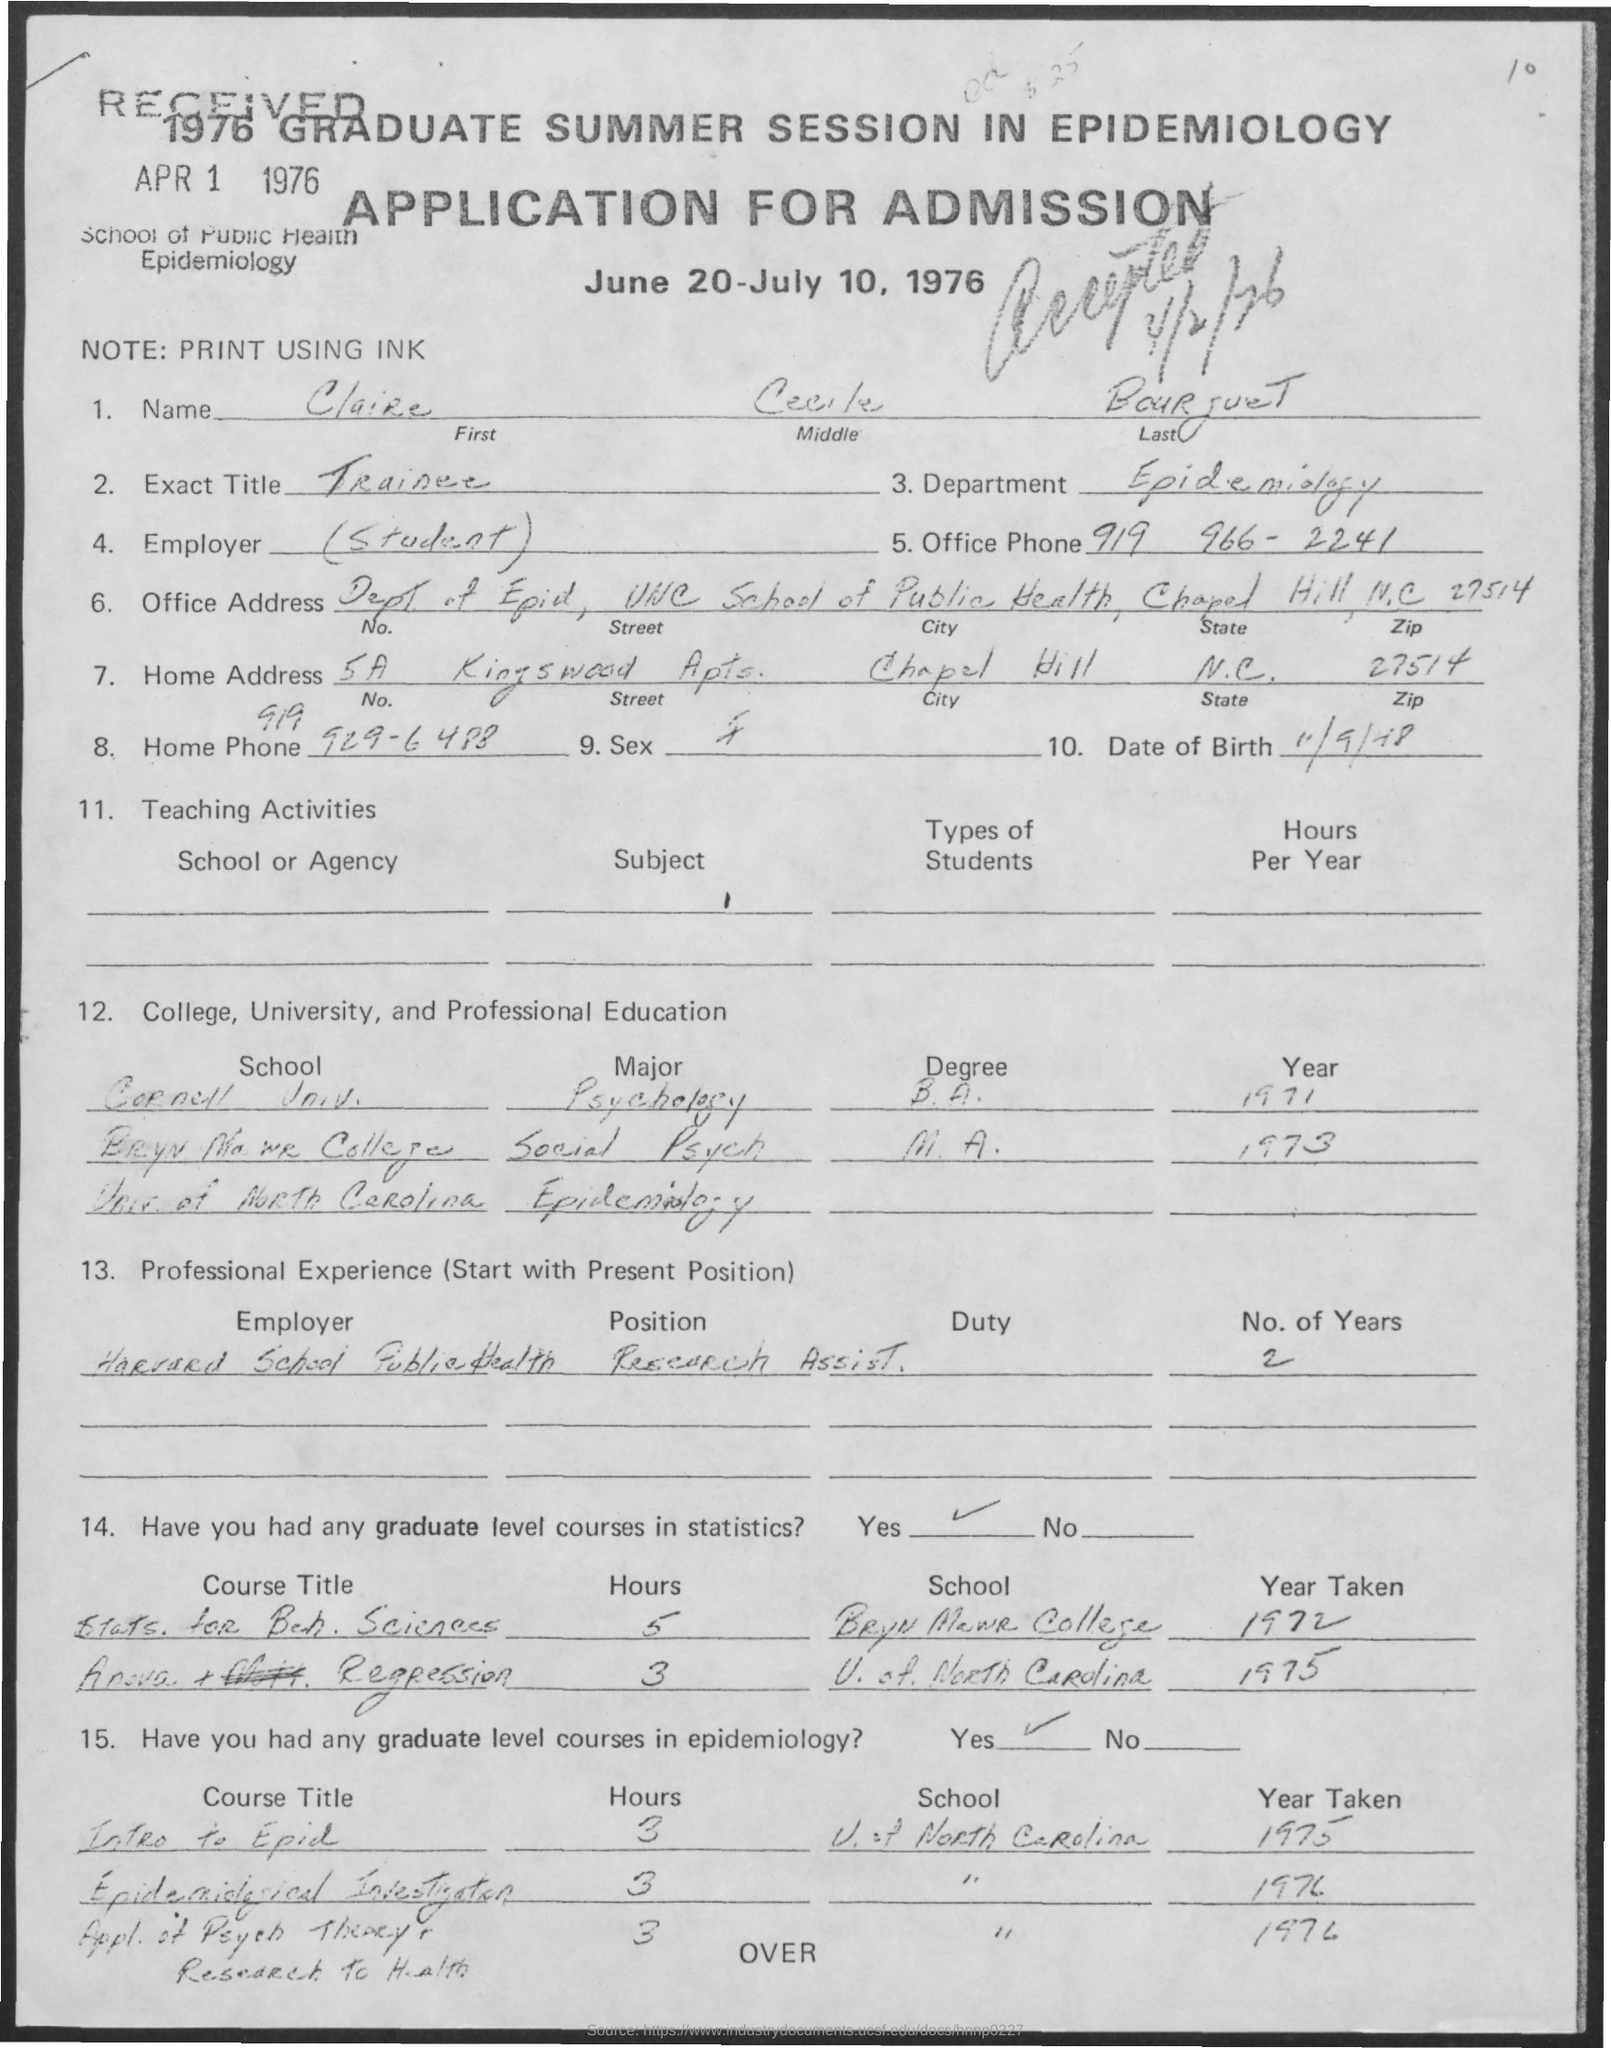Point out several critical features in this image. The title of the document is Application for Admission. I have been asked to inquire about the last name of an individual referred to as BOURJUET.. It is confirmed that the first name of the individual is Claire. The Department of Epidemiology is responsible for studying the patterns, causes, and control of diseases and other health-related issues in populations. The office phone number is 919 966-2241. 